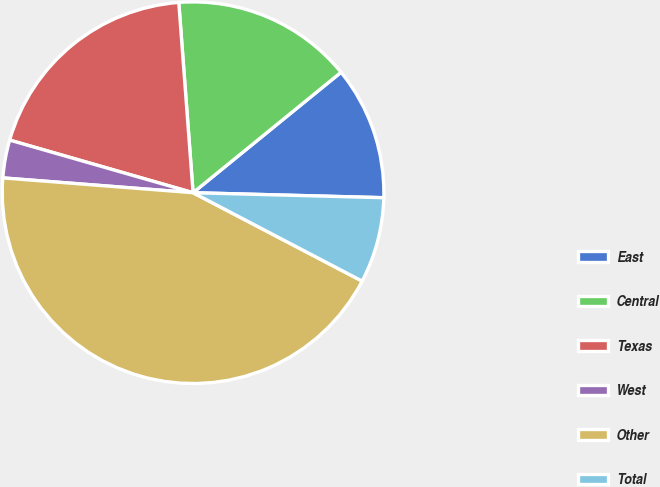Convert chart. <chart><loc_0><loc_0><loc_500><loc_500><pie_chart><fcel>East<fcel>Central<fcel>Texas<fcel>West<fcel>Other<fcel>Total<nl><fcel>11.29%<fcel>15.32%<fcel>19.36%<fcel>3.21%<fcel>43.57%<fcel>7.25%<nl></chart> 